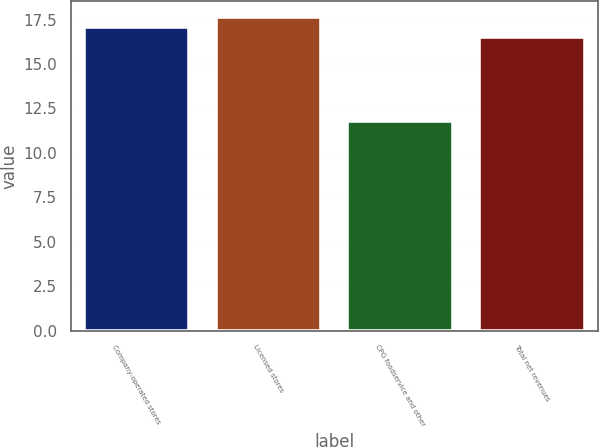Convert chart. <chart><loc_0><loc_0><loc_500><loc_500><bar_chart><fcel>Company-operated stores<fcel>Licensed stores<fcel>CPG foodservice and other<fcel>Total net revenues<nl><fcel>17.1<fcel>17.64<fcel>11.8<fcel>16.5<nl></chart> 